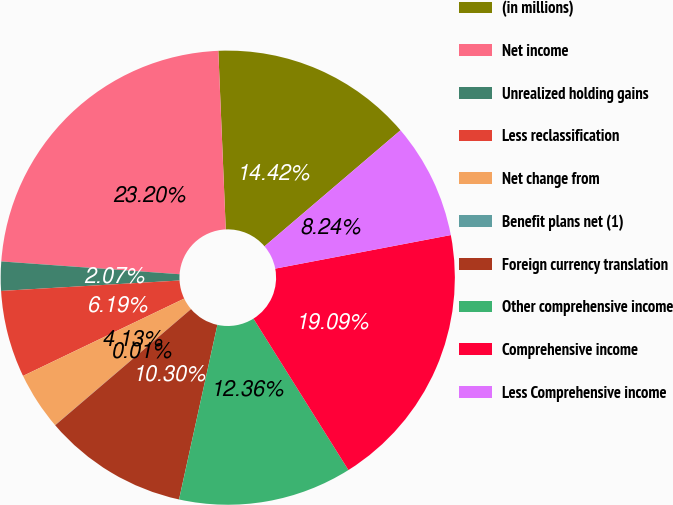Convert chart. <chart><loc_0><loc_0><loc_500><loc_500><pie_chart><fcel>(in millions)<fcel>Net income<fcel>Unrealized holding gains<fcel>Less reclassification<fcel>Net change from<fcel>Benefit plans net (1)<fcel>Foreign currency translation<fcel>Other comprehensive income<fcel>Comprehensive income<fcel>Less Comprehensive income<nl><fcel>14.42%<fcel>23.2%<fcel>2.07%<fcel>6.19%<fcel>4.13%<fcel>0.01%<fcel>10.3%<fcel>12.36%<fcel>19.09%<fcel>8.24%<nl></chart> 